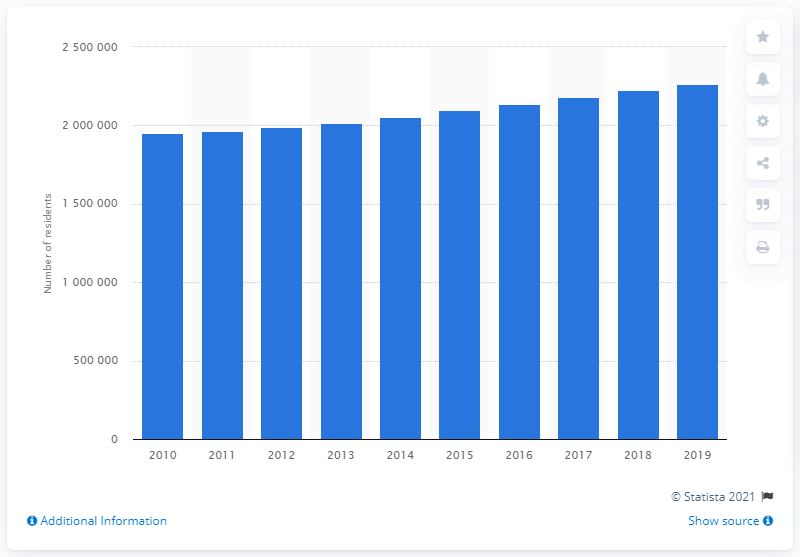Can you tell me more about what factors might contribute to this population growth in Las Vegas? Certainly! Population growth in Las Vegas is influenced by several factors, including its reputation as a major tourist destination, diverse employment opportunities, particularly in hospitality and gaming industries, and its relatively lower cost of living compared to other major metropolitan areas. Additionally, the area's warmer climate and favorable tax laws, such as no state income tax, are attractive to many. 